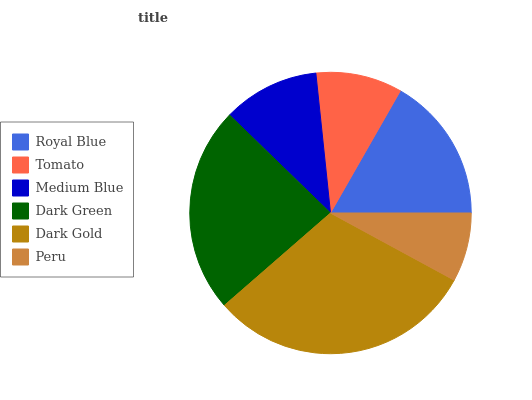Is Peru the minimum?
Answer yes or no. Yes. Is Dark Gold the maximum?
Answer yes or no. Yes. Is Tomato the minimum?
Answer yes or no. No. Is Tomato the maximum?
Answer yes or no. No. Is Royal Blue greater than Tomato?
Answer yes or no. Yes. Is Tomato less than Royal Blue?
Answer yes or no. Yes. Is Tomato greater than Royal Blue?
Answer yes or no. No. Is Royal Blue less than Tomato?
Answer yes or no. No. Is Royal Blue the high median?
Answer yes or no. Yes. Is Medium Blue the low median?
Answer yes or no. Yes. Is Tomato the high median?
Answer yes or no. No. Is Dark Green the low median?
Answer yes or no. No. 